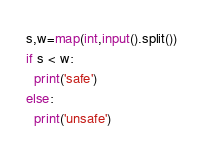<code> <loc_0><loc_0><loc_500><loc_500><_Python_>s,w=map(int,input().split())
if s < w:
  print('safe')
else:
  print('unsafe')</code> 